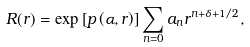Convert formula to latex. <formula><loc_0><loc_0><loc_500><loc_500>R ( r ) = \exp \left [ p \left ( \alpha , r \right ) \right ] \sum _ { n = 0 } a _ { n } r ^ { n + \delta + 1 / 2 } ,</formula> 